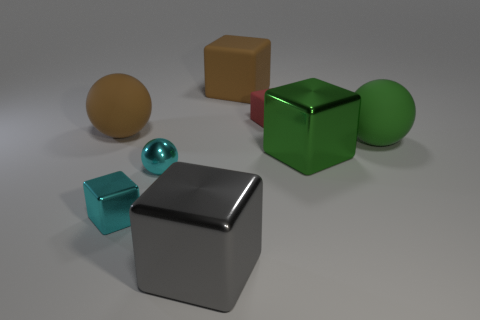Does the tiny block that is in front of the tiny matte cube have the same material as the large green sphere?
Give a very brief answer. No. How many small things are either green metallic things or metallic cubes?
Offer a terse response. 1. What size is the red thing?
Give a very brief answer. Small. Does the gray block have the same size as the cube that is behind the red rubber object?
Offer a very short reply. Yes. How many cyan objects are either small cubes or tiny objects?
Keep it short and to the point. 2. How many red things are there?
Your response must be concise. 1. What is the size of the brown block that is behind the big gray cube?
Make the answer very short. Large. Is the size of the gray metallic object the same as the cyan sphere?
Keep it short and to the point. No. What number of objects are small cyan balls or objects that are in front of the green cube?
Offer a terse response. 3. What material is the gray cube?
Give a very brief answer. Metal. 